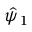<formula> <loc_0><loc_0><loc_500><loc_500>\hat { \psi } _ { 1 }</formula> 